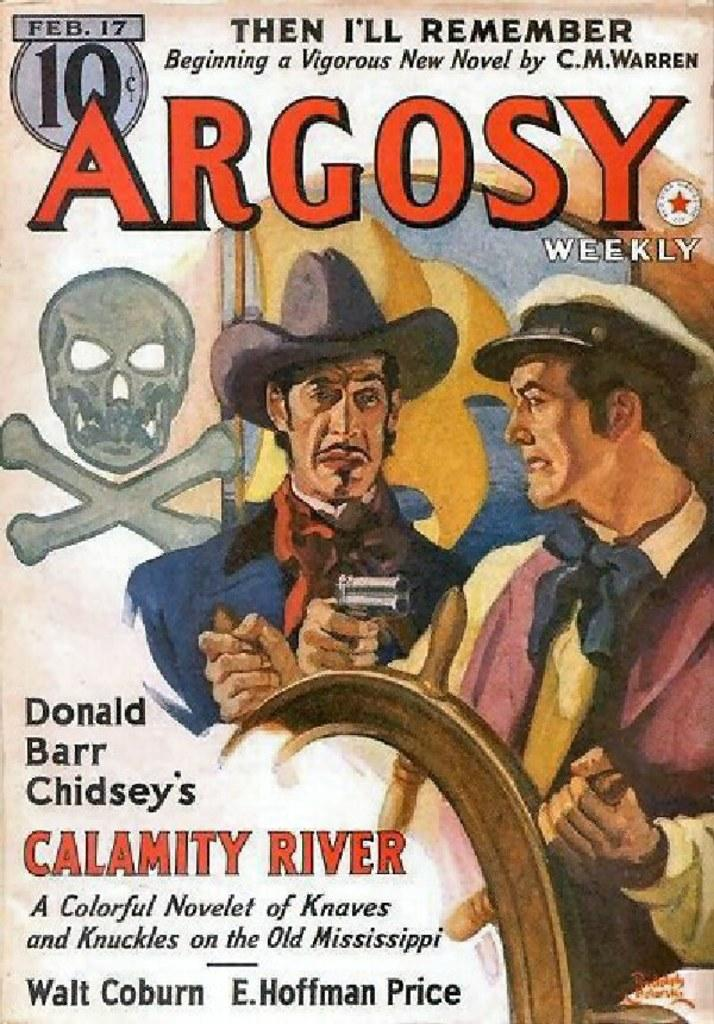What type of content is present in the image? The image contains an article and a painting. Can you describe the painting in the image? The painting contains two persons who are wearing hats and holding a wheel. What is the text at the top of the image? There is text at the top of the image, but we cannot determine its content from the image alone. What is the text at the bottom of the image? There is text at the bottom of the image, but we cannot determine its content from the image alone. What month is the painting set in? The image does not provide any information about the month or time period in which the painting is set. Can you tell me how many aunts are depicted in the painting? There are no aunts depicted in the painting; it features two persons who are wearing hats and holding a wheel. 